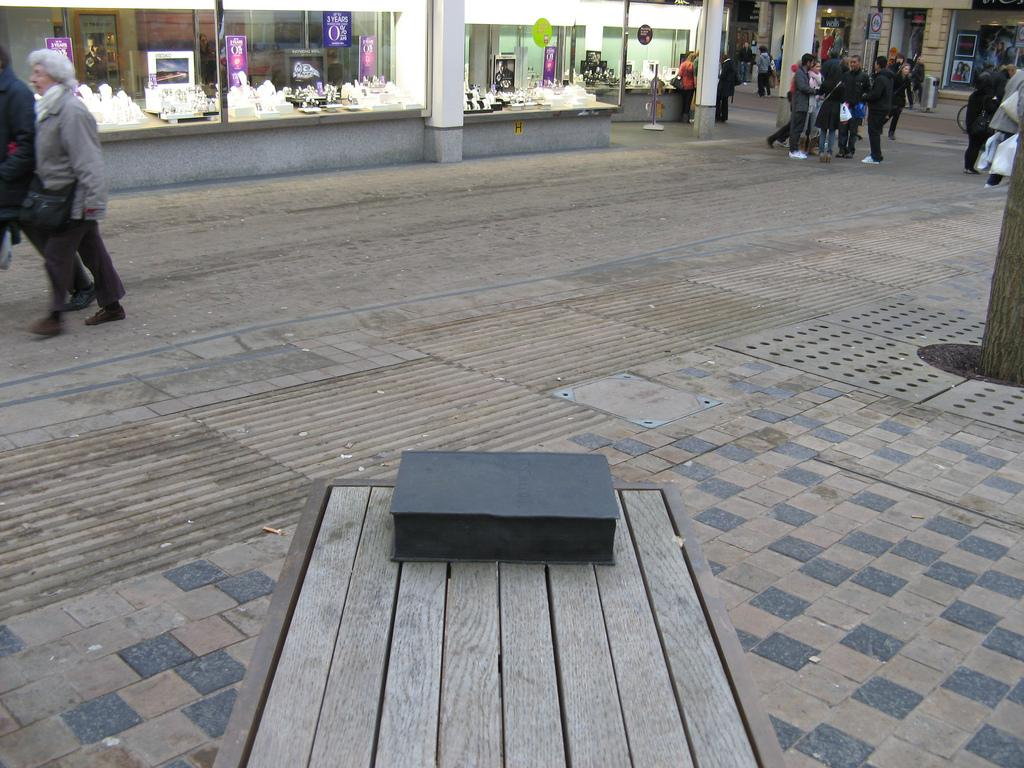Explain the different elements related to the wooden table in the image. The wooden table features a black box on its top and a hidden wooden plank secret door in the ground below it. What can be observed about the bike in the picture? The partially seen wheel of a bike can be observed in the image. What is the appearance of the walkway in the image? The walkway includes a brick portion of the sidewalk and people walking on it, with retail stores and multicolored bricks nearby. Describe the scene involving the group of people in the image. A group of people is shopping together, and one of them is holding a white bag in his hands. What kind of objects can be seen on the sidewalk? A tree stump and multicolored bricks can be seen on the sidewalk. What is unique about the tree trunk in the image? The tree trunk is partially visible and growing in a circular planter. Identify the object positioned at the end of the table. A black box is positioned at the end of the table. Provide a brief overview of the retail stores in the image. Various retail stores are present with store fronts that have green and purple ads and a window with green sign and purple posters. Describe the details of the woman in the grey coat. The woman in the grey coat has white hair, is carrying a black purse, and has a blurry left leg. What kind of day was this photo taken on? The picture was taken during the day. Write a factual description of the image. The image shows a city scene with people shopping, a black box on a table, store fronts with green and purple ads, and a tree trunk growing through the sidewalk. What is happening with the group of people in the bottom right corner of the image? They are shopping together. Is there a white cat sitting under the wooden table? The cat seems to be enjoying the sunny day outside. What is unique about the table in the image? It has a black box and a secret wooden plank door on it. Is there a white bag in this image? If yes, where is it placed? Yes, there is a white bag in a man's hands. Can you see the blue bird perched on a branch on the left side of the image? The blue bird is in sharp contrast with the green leaves around it. Describe the interaction between the tree trunk and the sidewalk. The tree trunk breaks the pavement as it grows through it. Analyze the setting of this image based on the context. The picture was taken during the day in an urban environment with various retail stores. Find the brick portions of the sidewalk in the image. Located around the scene, especially at the bottom and right sides. Is a small brown dog chasing a squirrel next to the brick sidewalk? The dog's owner is trying to catch up to them in the background. Do you spot the red car parked in front of the store with a green sign? The driver went into the store to buy some groceries. Identify the position of the metal divider in the image. The metal divider is located in a window near the left edge. Select which description best describes the scene in the image. Options: (A) People having a picnic in a forest. (B) Group of people shopping in a city. (C) A beach with colorful umbrellas. (D) An amusement park with rides. (B) Group of people shopping in a city. What is the large black object on the table? It is a large black book sculpture. Describe the woman in the grey coat. She has a blurry left leg and is carrying a black purse. Which sentences describe people in the image? (A) Dogs running around (B) a woman in a gray coat (C) Animals on the beach (D) a man in black jeans (B) a woman in a gray coat and (D) a man in black jeans Which tree trunk is growing within a circular planter? The tree trunk that is partially visible in the image. Identify the location of the bike wheel in the image. The wheel is partially visible at the bottom right. What color are the posters shown at the store fronts? Green and purple. Find the hidden yellow umbrella near the tree trunk. The yellow umbrella belongs to a young child who is playing nearby. Relate the appearance of the old lady in the image. The old lady has grey hair. What are the significant architectural components of the buildings in the image? White and grey pillars, store fronts with ads, and a cement pillar on the wall. Observe the bright pink flower blooming next to the circular planter. The flower is a rare species attracting many tourists. What activity is taking place in the image? People are walking on the sidewalk, shopping, and interacting with the environment. Describe the image in a poetic style. In a bustling city scene, life unfolds as leaves unfurl, on tree trunks, grey coats, and secret wooden planks, a black box whispers its silent tale atop its perch on wood. 